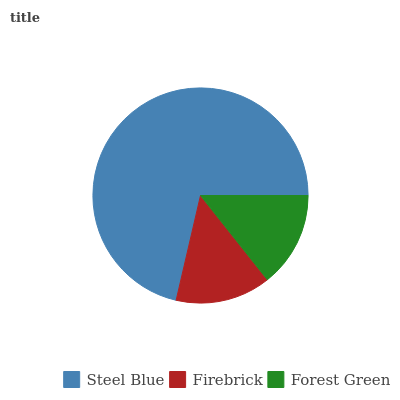Is Firebrick the minimum?
Answer yes or no. Yes. Is Steel Blue the maximum?
Answer yes or no. Yes. Is Forest Green the minimum?
Answer yes or no. No. Is Forest Green the maximum?
Answer yes or no. No. Is Forest Green greater than Firebrick?
Answer yes or no. Yes. Is Firebrick less than Forest Green?
Answer yes or no. Yes. Is Firebrick greater than Forest Green?
Answer yes or no. No. Is Forest Green less than Firebrick?
Answer yes or no. No. Is Forest Green the high median?
Answer yes or no. Yes. Is Forest Green the low median?
Answer yes or no. Yes. Is Steel Blue the high median?
Answer yes or no. No. Is Firebrick the low median?
Answer yes or no. No. 